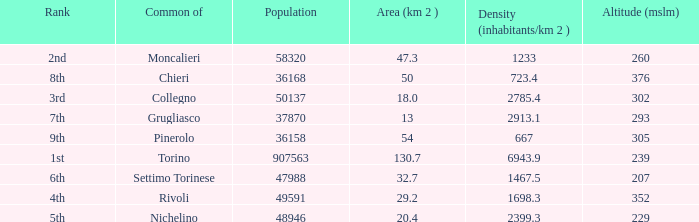What is the name of the 9th ranked common? Pinerolo. 